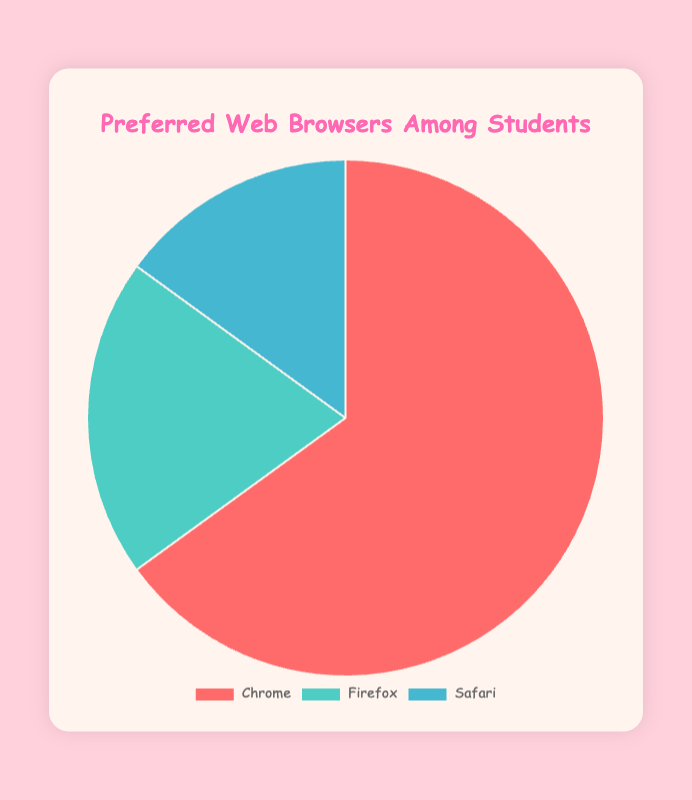What is the most preferred web browser among students? The pie chart shows three browser options with their percentages. Chrome has the largest slice, indicating it is the most preferred with 65%.
Answer: Chrome Which web browser is the least preferred among students? Safari has the smallest slice in the pie chart, indicating it is the least preferred with 15%.
Answer: Safari How much more preferred is Chrome compared to Firefox? Chrome has 65%, and Firefox has 20%. The difference is calculated by subtracting Firefox's percentage from Chrome's percentage (65% - 20% = 45%).
Answer: 45% What is the combined percentage of students who prefer Firefox and Safari? Add the percentages of Firefox and Safari (20% + 15% = 35%).
Answer: 35% What percentage of students prefer browsers other than Chrome? Add the percentages of Firefox and Safari to get the total percentage of students who do not prefer Chrome (20% + 15% = 35%).
Answer: 35% Are there more students who prefer Chrome than those who prefer Firefox and Safari combined? The combined percentage of Firefox and Safari is 35%, while Chrome alone is 65%. Because 65% > 35%, more students prefer Chrome than Firefox and Safari combined.
Answer: Yes Which browser has the second highest preference among students? After Chrome (65%), Firefox has the second highest preference with 20% as shown in the pie chart.
Answer: Firefox What is the difference between the preferences for Firefox and Safari? The pie chart shows Firefox at 20% and Safari at 15%. The difference is calculated by subtracting Safari's percentage from Firefox's percentage (20% - 15% = 5%).
Answer: 5% What fraction of the pie chart represents students who prefer Safari? Safari represents 15% of the pie chart. Converting this to a fraction of the whole (which is 100%), it is 15/100 or simplified to 3/20.
Answer: 3/20 If there are 200 students, how many of them prefer Chrome? With 65% of students preferring Chrome and a total of 200 students, multiply 200 by 65% (0.65). 200 * 0.65 = 130 students.
Answer: 130 students 